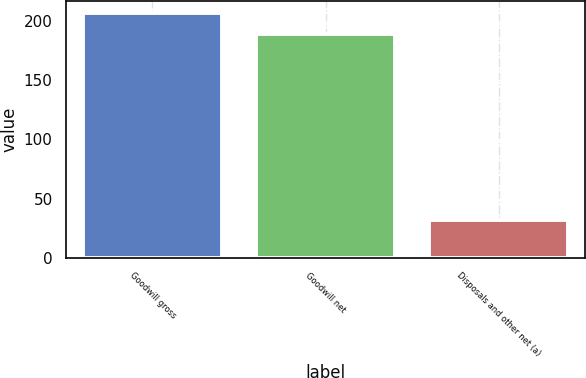<chart> <loc_0><loc_0><loc_500><loc_500><bar_chart><fcel>Goodwill gross<fcel>Goodwill net<fcel>Disposals and other net (a)<nl><fcel>206.4<fcel>189<fcel>32<nl></chart> 